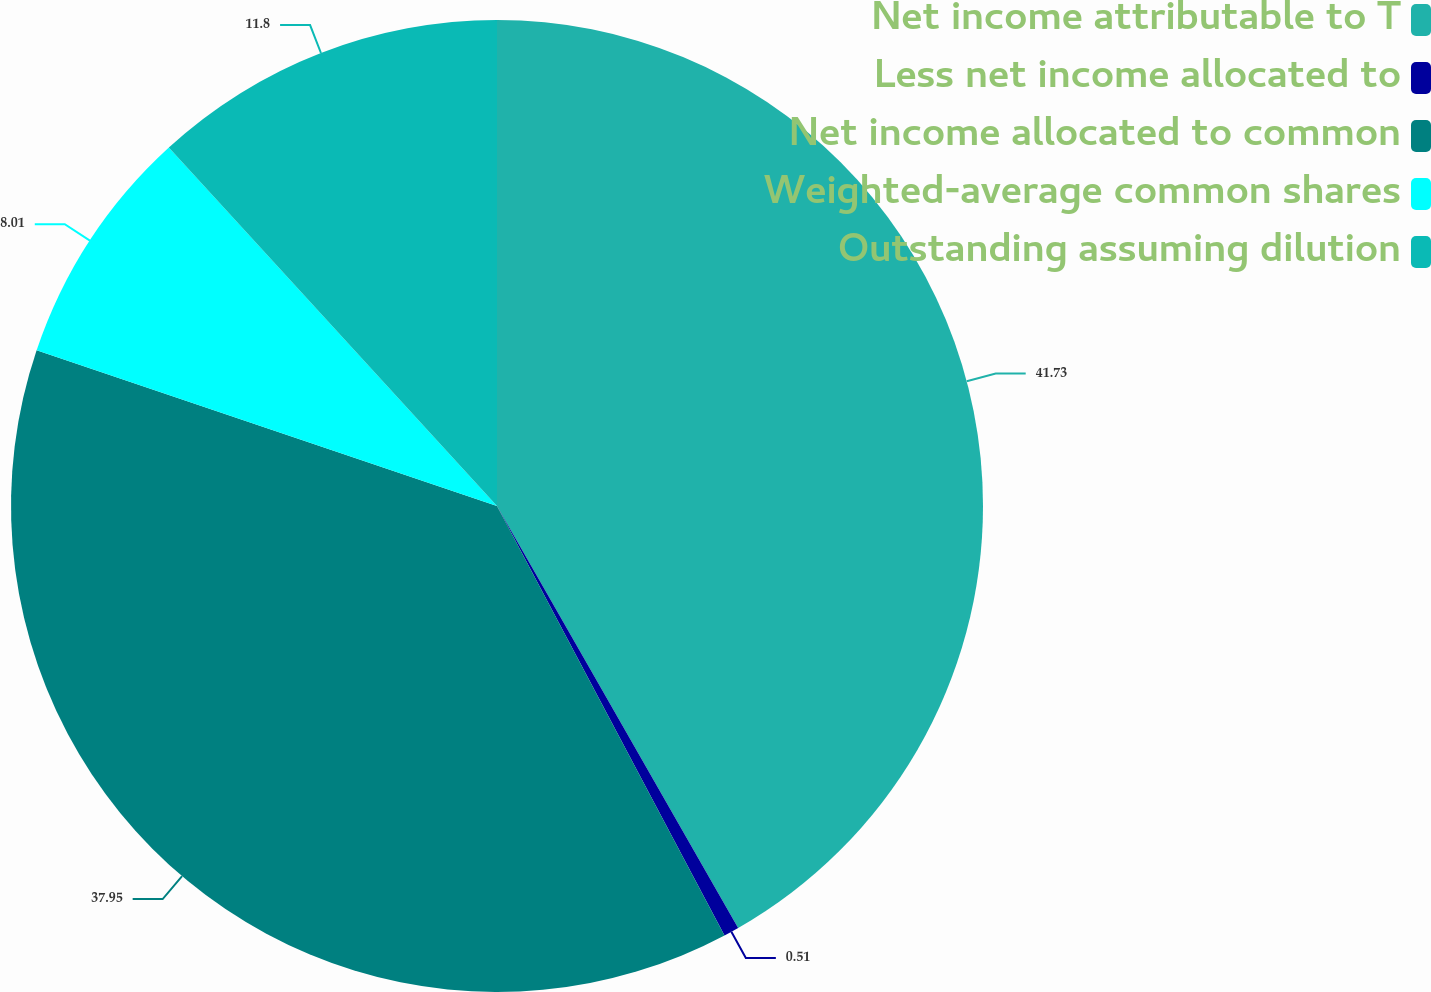Convert chart. <chart><loc_0><loc_0><loc_500><loc_500><pie_chart><fcel>Net income attributable to T<fcel>Less net income allocated to<fcel>Net income allocated to common<fcel>Weighted-average common shares<fcel>Outstanding assuming dilution<nl><fcel>41.74%<fcel>0.51%<fcel>37.95%<fcel>8.01%<fcel>11.8%<nl></chart> 